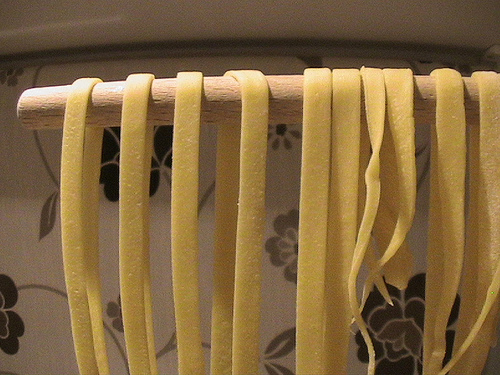<image>
Is the noodle on the bar? Yes. Looking at the image, I can see the noodle is positioned on top of the bar, with the bar providing support. 